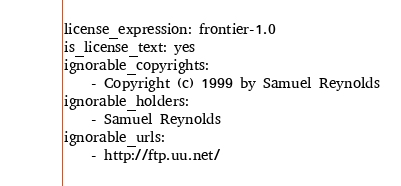Convert code to text. <code><loc_0><loc_0><loc_500><loc_500><_YAML_>license_expression: frontier-1.0
is_license_text: yes
ignorable_copyrights:
    - Copyright (c) 1999 by Samuel Reynolds
ignorable_holders:
    - Samuel Reynolds
ignorable_urls:
    - http://ftp.uu.net/
</code> 